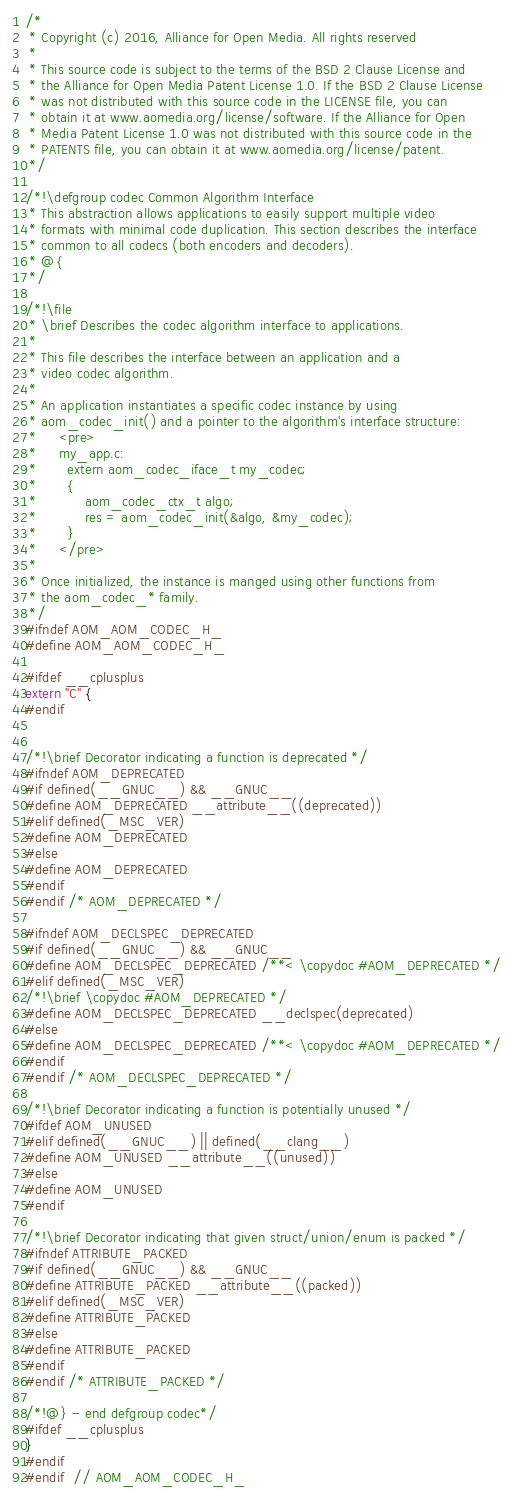<code> <loc_0><loc_0><loc_500><loc_500><_C_>/*
 * Copyright (c) 2016, Alliance for Open Media. All rights reserved
 *
 * This source code is subject to the terms of the BSD 2 Clause License and
 * the Alliance for Open Media Patent License 1.0. If the BSD 2 Clause License
 * was not distributed with this source code in the LICENSE file, you can
 * obtain it at www.aomedia.org/license/software. If the Alliance for Open
 * Media Patent License 1.0 was not distributed with this source code in the
 * PATENTS file, you can obtain it at www.aomedia.org/license/patent.
 */

/*!\defgroup codec Common Algorithm Interface
 * This abstraction allows applications to easily support multiple video
 * formats with minimal code duplication. This section describes the interface
 * common to all codecs (both encoders and decoders).
 * @{
 */

/*!\file
 * \brief Describes the codec algorithm interface to applications.
 *
 * This file describes the interface between an application and a
 * video codec algorithm.
 *
 * An application instantiates a specific codec instance by using
 * aom_codec_init() and a pointer to the algorithm's interface structure:
 *     <pre>
 *     my_app.c:
 *       extern aom_codec_iface_t my_codec;
 *       {
 *           aom_codec_ctx_t algo;
 *           res = aom_codec_init(&algo, &my_codec);
 *       }
 *     </pre>
 *
 * Once initialized, the instance is manged using other functions from
 * the aom_codec_* family.
 */
#ifndef AOM_AOM_CODEC_H_
#define AOM_AOM_CODEC_H_

#ifdef __cplusplus
extern "C" {
#endif


/*!\brief Decorator indicating a function is deprecated */
#ifndef AOM_DEPRECATED
#if defined(__GNUC__) && __GNUC__
#define AOM_DEPRECATED __attribute__((deprecated))
#elif defined(_MSC_VER)
#define AOM_DEPRECATED
#else
#define AOM_DEPRECATED
#endif
#endif /* AOM_DEPRECATED */

#ifndef AOM_DECLSPEC_DEPRECATED
#if defined(__GNUC__) && __GNUC__
#define AOM_DECLSPEC_DEPRECATED /**< \copydoc #AOM_DEPRECATED */
#elif defined(_MSC_VER)
/*!\brief \copydoc #AOM_DEPRECATED */
#define AOM_DECLSPEC_DEPRECATED __declspec(deprecated)
#else
#define AOM_DECLSPEC_DEPRECATED /**< \copydoc #AOM_DEPRECATED */
#endif
#endif /* AOM_DECLSPEC_DEPRECATED */

/*!\brief Decorator indicating a function is potentially unused */
#ifdef AOM_UNUSED
#elif defined(__GNUC__) || defined(__clang__)
#define AOM_UNUSED __attribute__((unused))
#else
#define AOM_UNUSED
#endif

/*!\brief Decorator indicating that given struct/union/enum is packed */
#ifndef ATTRIBUTE_PACKED
#if defined(__GNUC__) && __GNUC__
#define ATTRIBUTE_PACKED __attribute__((packed))
#elif defined(_MSC_VER)
#define ATTRIBUTE_PACKED
#else
#define ATTRIBUTE_PACKED
#endif
#endif /* ATTRIBUTE_PACKED */

/*!@} - end defgroup codec*/
#ifdef __cplusplus
}
#endif
#endif  // AOM_AOM_CODEC_H_
</code> 